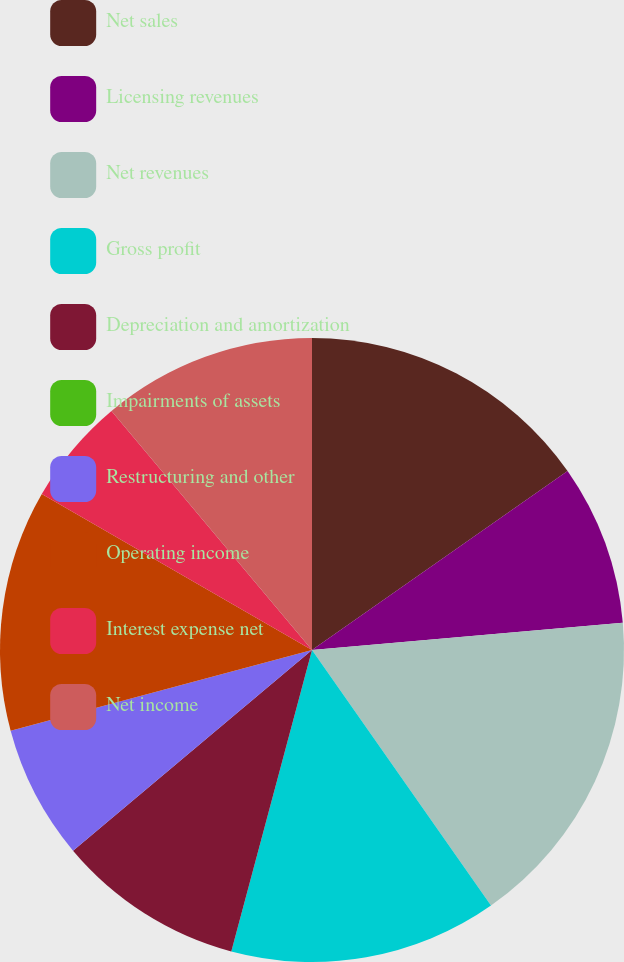<chart> <loc_0><loc_0><loc_500><loc_500><pie_chart><fcel>Net sales<fcel>Licensing revenues<fcel>Net revenues<fcel>Gross profit<fcel>Depreciation and amortization<fcel>Impairments of assets<fcel>Restructuring and other<fcel>Operating income<fcel>Interest expense net<fcel>Net income<nl><fcel>15.28%<fcel>8.33%<fcel>16.67%<fcel>13.89%<fcel>9.72%<fcel>0.0%<fcel>6.95%<fcel>12.5%<fcel>5.56%<fcel>11.11%<nl></chart> 